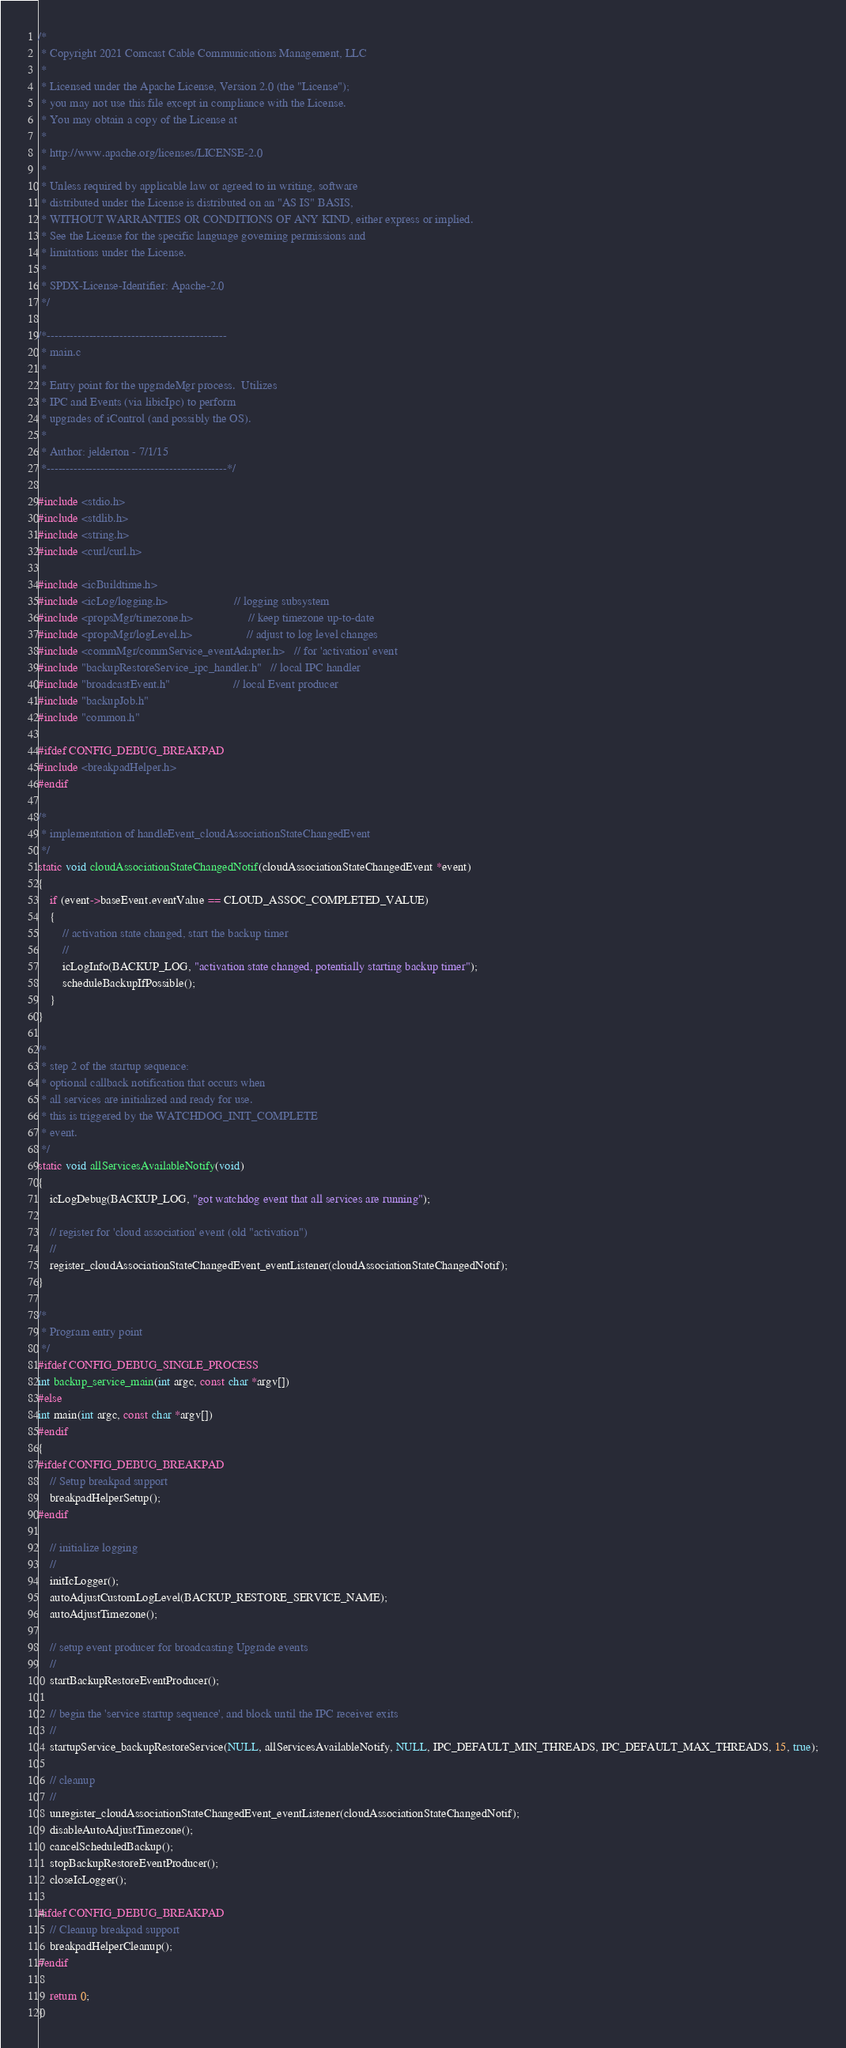Convert code to text. <code><loc_0><loc_0><loc_500><loc_500><_C_>/*
 * Copyright 2021 Comcast Cable Communications Management, LLC
 *
 * Licensed under the Apache License, Version 2.0 (the "License");
 * you may not use this file except in compliance with the License.
 * You may obtain a copy of the License at
 *
 * http://www.apache.org/licenses/LICENSE-2.0
 *
 * Unless required by applicable law or agreed to in writing, software
 * distributed under the License is distributed on an "AS IS" BASIS,
 * WITHOUT WARRANTIES OR CONDITIONS OF ANY KIND, either express or implied.
 * See the License for the specific language governing permissions and
 * limitations under the License.
 *
 * SPDX-License-Identifier: Apache-2.0
 */

/*-----------------------------------------------
 * main.c
 *
 * Entry point for the upgradeMgr process.  Utilizes
 * IPC and Events (via libicIpc) to perform
 * upgrades of iControl (and possibly the OS).
 *
 * Author: jelderton - 7/1/15
 *-----------------------------------------------*/

#include <stdio.h>
#include <stdlib.h>
#include <string.h>
#include <curl/curl.h>

#include <icBuildtime.h>
#include <icLog/logging.h>                      // logging subsystem
#include <propsMgr/timezone.h>                  // keep timezone up-to-date
#include <propsMgr/logLevel.h>                  // adjust to log level changes
#include <commMgr/commService_eventAdapter.h>   // for 'activation' event
#include "backupRestoreService_ipc_handler.h"   // local IPC handler
#include "broadcastEvent.h"                     // local Event producer
#include "backupJob.h"
#include "common.h"

#ifdef CONFIG_DEBUG_BREAKPAD
#include <breakpadHelper.h>
#endif

/*
 * implementation of handleEvent_cloudAssociationStateChangedEvent
 */
static void cloudAssociationStateChangedNotif(cloudAssociationStateChangedEvent *event)
{
    if (event->baseEvent.eventValue == CLOUD_ASSOC_COMPLETED_VALUE)
    {
        // activation state changed, start the backup timer
        //
        icLogInfo(BACKUP_LOG, "activation state changed, potentially starting backup timer");
        scheduleBackupIfPossible();
    }
}

/*
 * step 2 of the startup sequence:
 * optional callback notification that occurs when
 * all services are initialized and ready for use.
 * this is triggered by the WATCHDOG_INIT_COMPLETE
 * event.
 */
static void allServicesAvailableNotify(void)
{
    icLogDebug(BACKUP_LOG, "got watchdog event that all services are running");

    // register for 'cloud association' event (old "activation")
    //
    register_cloudAssociationStateChangedEvent_eventListener(cloudAssociationStateChangedNotif);
}

/*
 * Program entry point
 */
#ifdef CONFIG_DEBUG_SINGLE_PROCESS
int backup_service_main(int argc, const char *argv[])
#else
int main(int argc, const char *argv[])
#endif
{
#ifdef CONFIG_DEBUG_BREAKPAD
    // Setup breakpad support
    breakpadHelperSetup();
#endif

    // initialize logging
    //
    initIcLogger();
    autoAdjustCustomLogLevel(BACKUP_RESTORE_SERVICE_NAME);
    autoAdjustTimezone();

    // setup event producer for broadcasting Upgrade events
    //
    startBackupRestoreEventProducer();

    // begin the 'service startup sequence', and block until the IPC receiver exits
    //
    startupService_backupRestoreService(NULL, allServicesAvailableNotify, NULL, IPC_DEFAULT_MIN_THREADS, IPC_DEFAULT_MAX_THREADS, 15, true);

    // cleanup
    //
    unregister_cloudAssociationStateChangedEvent_eventListener(cloudAssociationStateChangedNotif);
    disableAutoAdjustTimezone();
    cancelScheduledBackup();
    stopBackupRestoreEventProducer();
    closeIcLogger();

#ifdef CONFIG_DEBUG_BREAKPAD
    // Cleanup breakpad support
    breakpadHelperCleanup();
#endif

    return 0;
}


</code> 